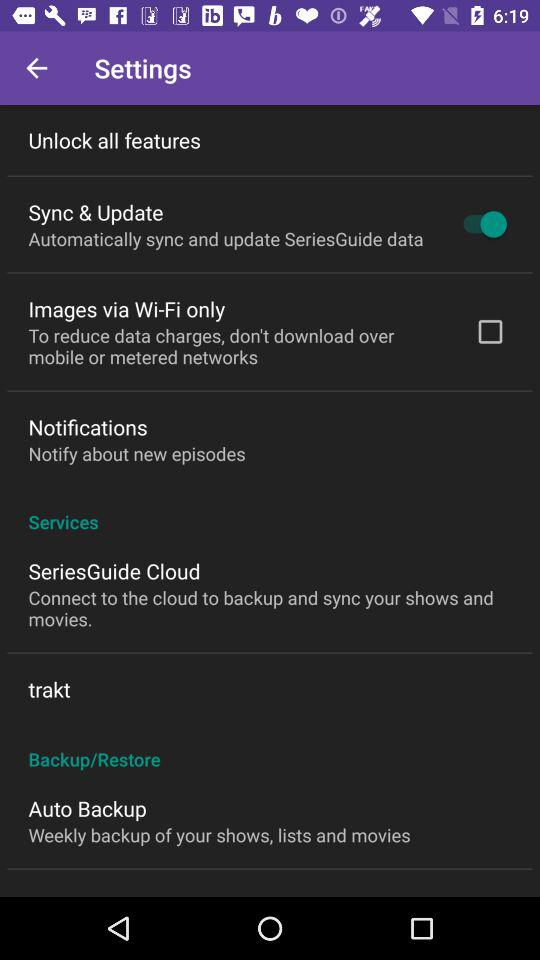What is the status of the sync and update? The status is on. 